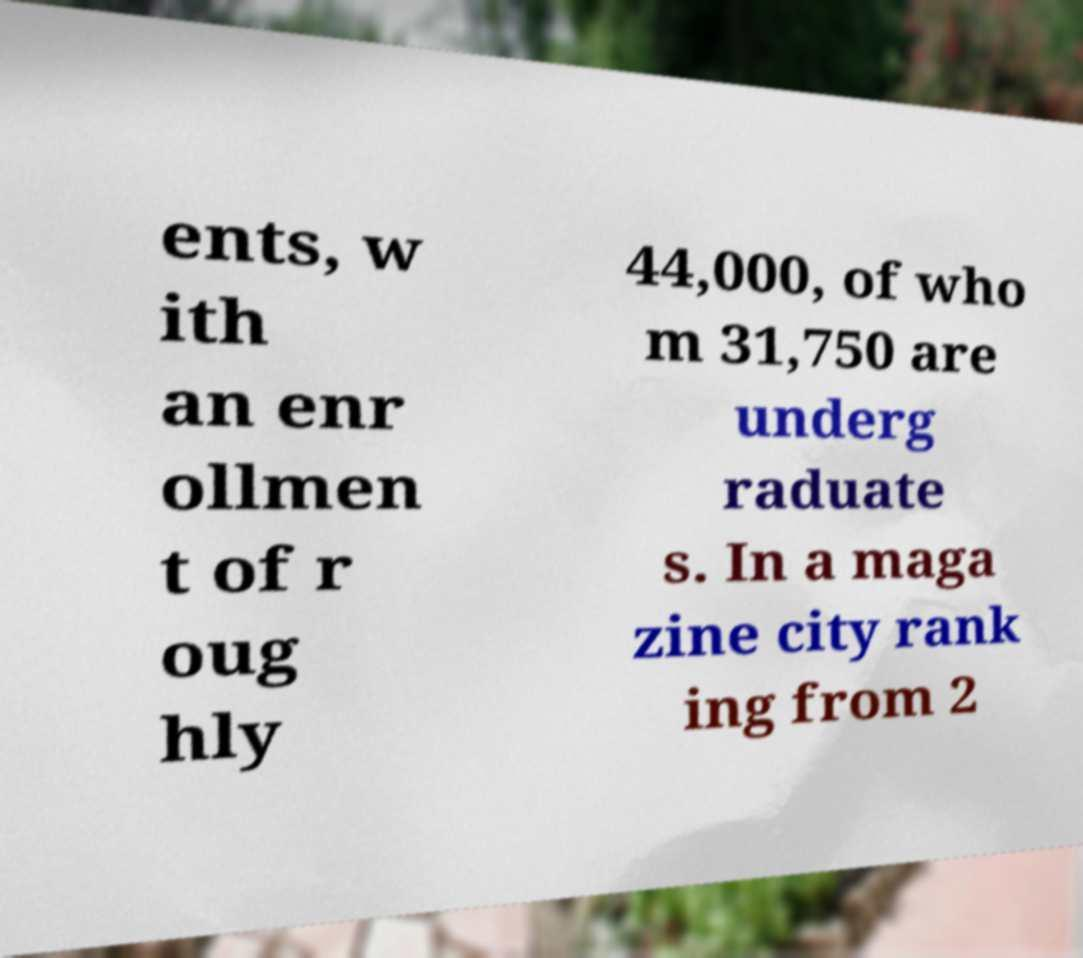Can you read and provide the text displayed in the image?This photo seems to have some interesting text. Can you extract and type it out for me? ents, w ith an enr ollmen t of r oug hly 44,000, of who m 31,750 are underg raduate s. In a maga zine city rank ing from 2 